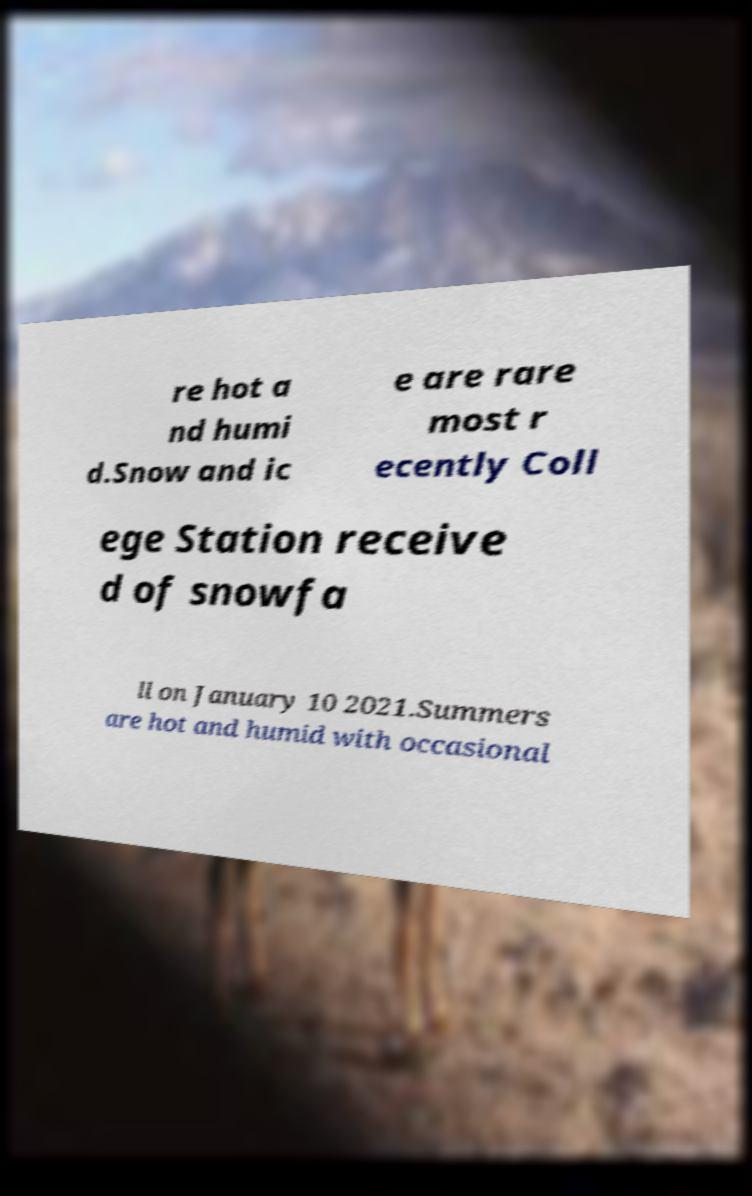Could you extract and type out the text from this image? re hot a nd humi d.Snow and ic e are rare most r ecently Coll ege Station receive d of snowfa ll on January 10 2021.Summers are hot and humid with occasional 